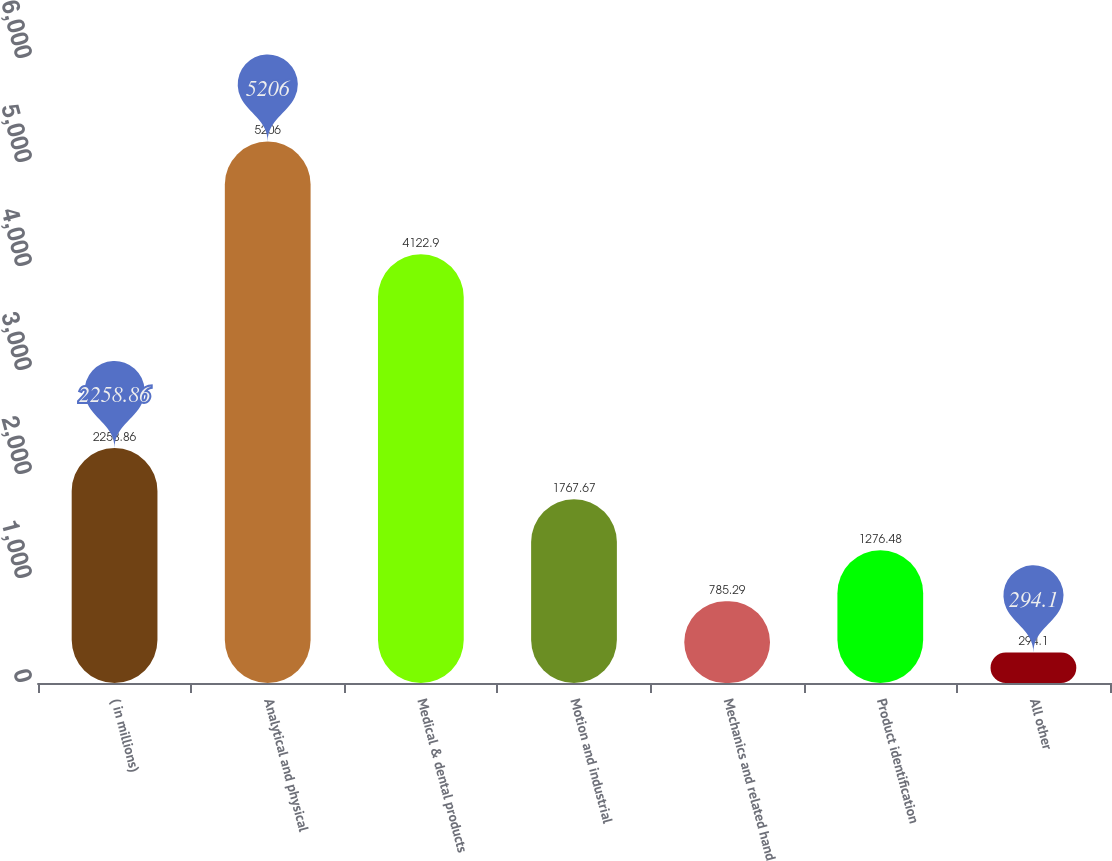<chart> <loc_0><loc_0><loc_500><loc_500><bar_chart><fcel>( in millions)<fcel>Analytical and physical<fcel>Medical & dental products<fcel>Motion and industrial<fcel>Mechanics and related hand<fcel>Product identification<fcel>All other<nl><fcel>2258.86<fcel>5206<fcel>4122.9<fcel>1767.67<fcel>785.29<fcel>1276.48<fcel>294.1<nl></chart> 